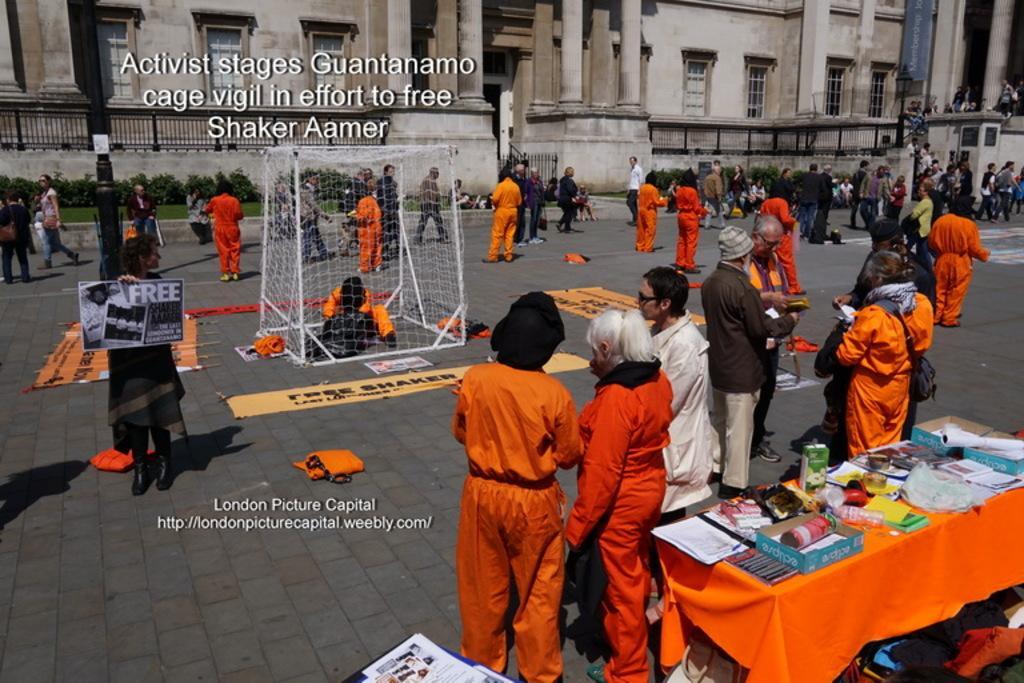Describe this image in one or two sentences. In this picture I can see a table in front on which there are number of things and I see number of people on the path and in the middle of this picture I see a net and I see something is written on the path. In the background I see the buildings and in front of the buildings I see the planets and I see the watermark on the top of this picture and bottom of this picture. 